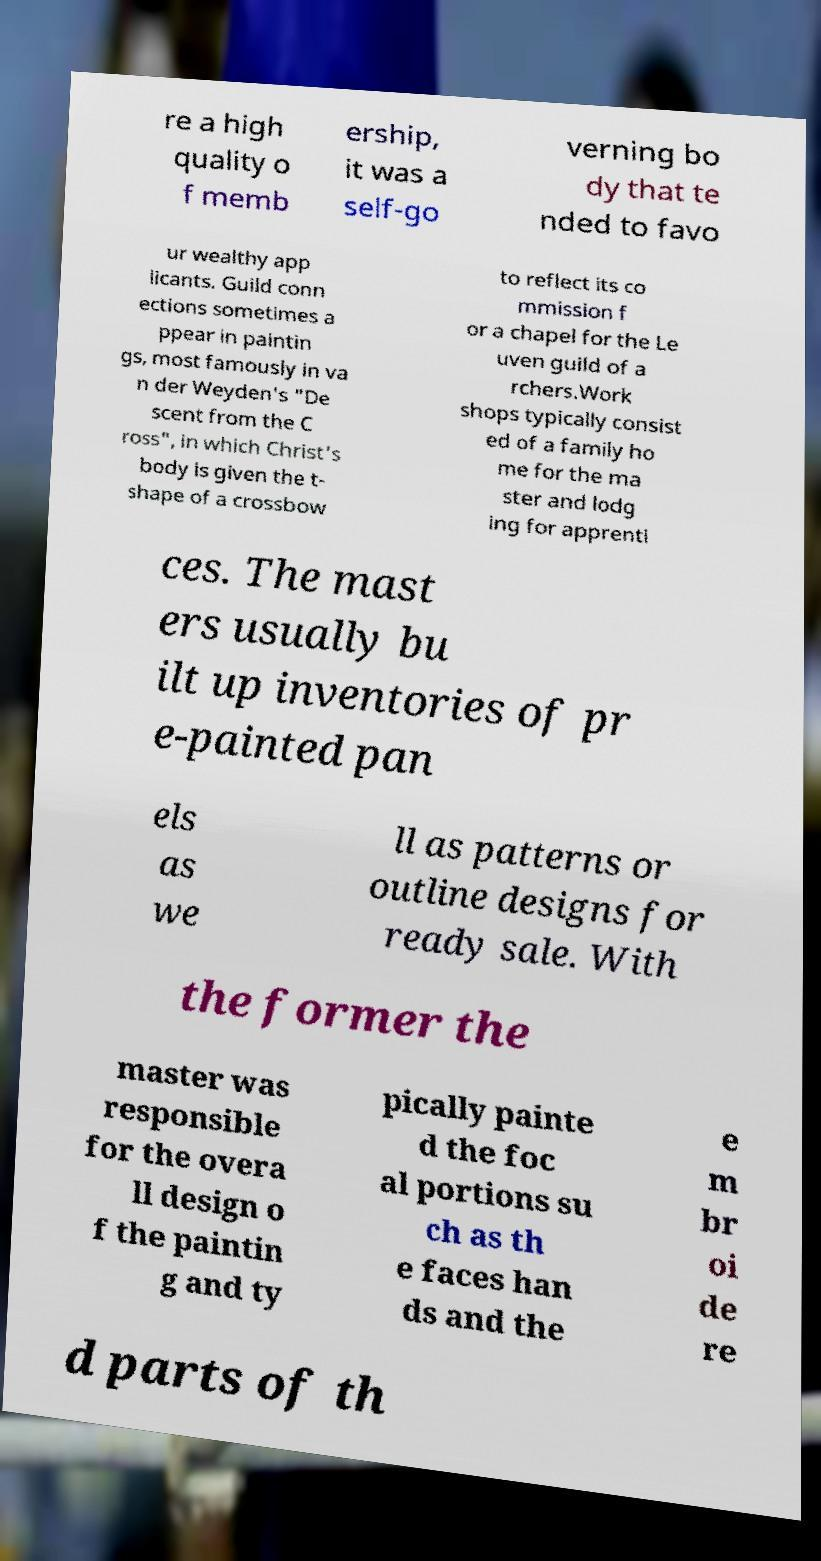Please identify and transcribe the text found in this image. re a high quality o f memb ership, it was a self-go verning bo dy that te nded to favo ur wealthy app licants. Guild conn ections sometimes a ppear in paintin gs, most famously in va n der Weyden's "De scent from the C ross", in which Christ's body is given the t- shape of a crossbow to reflect its co mmission f or a chapel for the Le uven guild of a rchers.Work shops typically consist ed of a family ho me for the ma ster and lodg ing for apprenti ces. The mast ers usually bu ilt up inventories of pr e-painted pan els as we ll as patterns or outline designs for ready sale. With the former the master was responsible for the overa ll design o f the paintin g and ty pically painte d the foc al portions su ch as th e faces han ds and the e m br oi de re d parts of th 